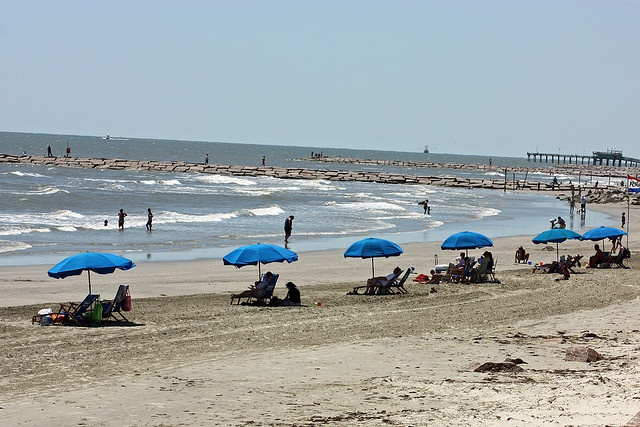Describe the objects in this image and their specific colors. I can see people in lightblue, black, darkgray, gray, and lightgray tones, umbrella in lightblue, gray, black, and blue tones, umbrella in lightblue, blue, gray, and black tones, umbrella in lightblue, blue, navy, black, and gray tones, and chair in lightblue, black, gray, and maroon tones in this image. 